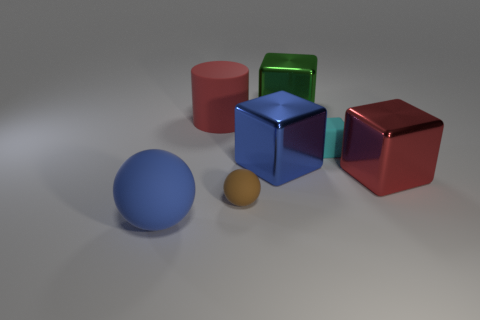There is a shiny thing that is to the left of the green metallic cube; is its size the same as the red shiny cube?
Your response must be concise. Yes. There is a thing that is right of the tiny matte ball and left of the green shiny cube; what color is it?
Keep it short and to the point. Blue. What number of things are either big red rubber cylinders or tiny rubber things in front of the cyan block?
Offer a terse response. 2. What is the material of the block behind the red thing that is on the left side of the big shiny block on the right side of the cyan matte thing?
Make the answer very short. Metal. Does the small matte thing that is right of the blue cube have the same color as the cylinder?
Ensure brevity in your answer.  No. What number of red things are tiny shiny balls or cylinders?
Your answer should be compact. 1. How many other objects are the same shape as the brown rubber object?
Make the answer very short. 1. Does the large blue sphere have the same material as the tiny brown ball?
Offer a very short reply. Yes. What is the material of the large object that is left of the red block and in front of the blue shiny object?
Your answer should be very brief. Rubber. What is the color of the tiny rubber ball in front of the large red matte cylinder?
Your answer should be very brief. Brown. 